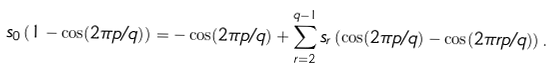Convert formula to latex. <formula><loc_0><loc_0><loc_500><loc_500>s _ { 0 } \left ( 1 - \cos ( 2 \pi p / q ) \right ) = - \cos ( 2 \pi p / q ) + \sum _ { r = 2 } ^ { q - 1 } s _ { r } \left ( \cos ( 2 \pi p / q ) - \cos ( 2 \pi r p / q ) \right ) .</formula> 